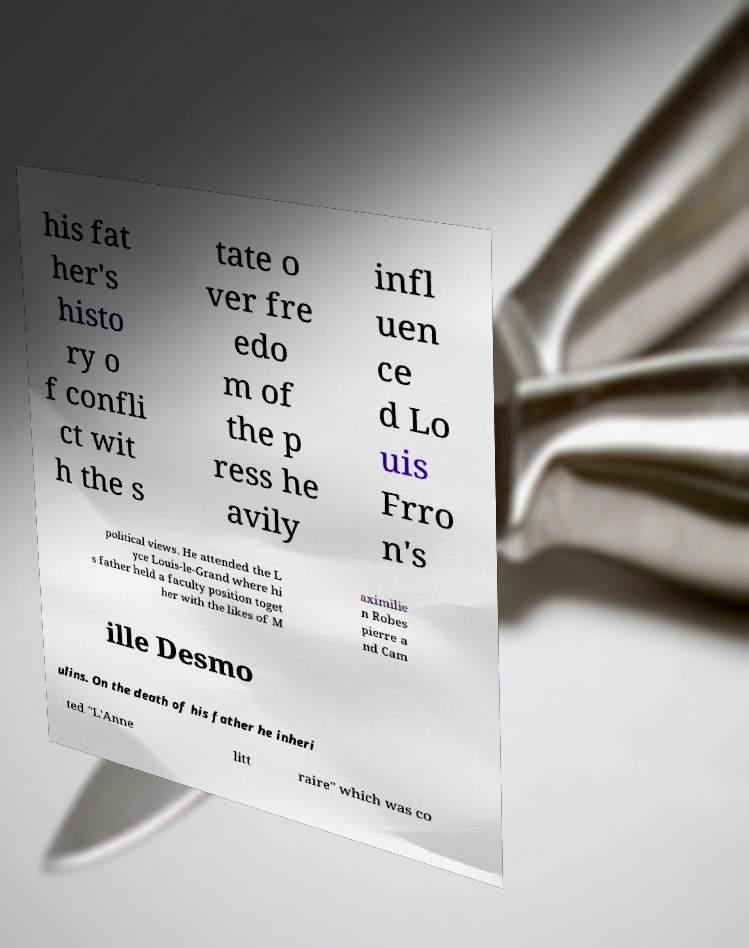I need the written content from this picture converted into text. Can you do that? his fat her's histo ry o f confli ct wit h the s tate o ver fre edo m of the p ress he avily infl uen ce d Lo uis Frro n's political views. He attended the L yce Louis-le-Grand where hi s father held a faculty position toget her with the likes of M aximilie n Robes pierre a nd Cam ille Desmo ulins. On the death of his father he inheri ted "L'Anne litt raire" which was co 